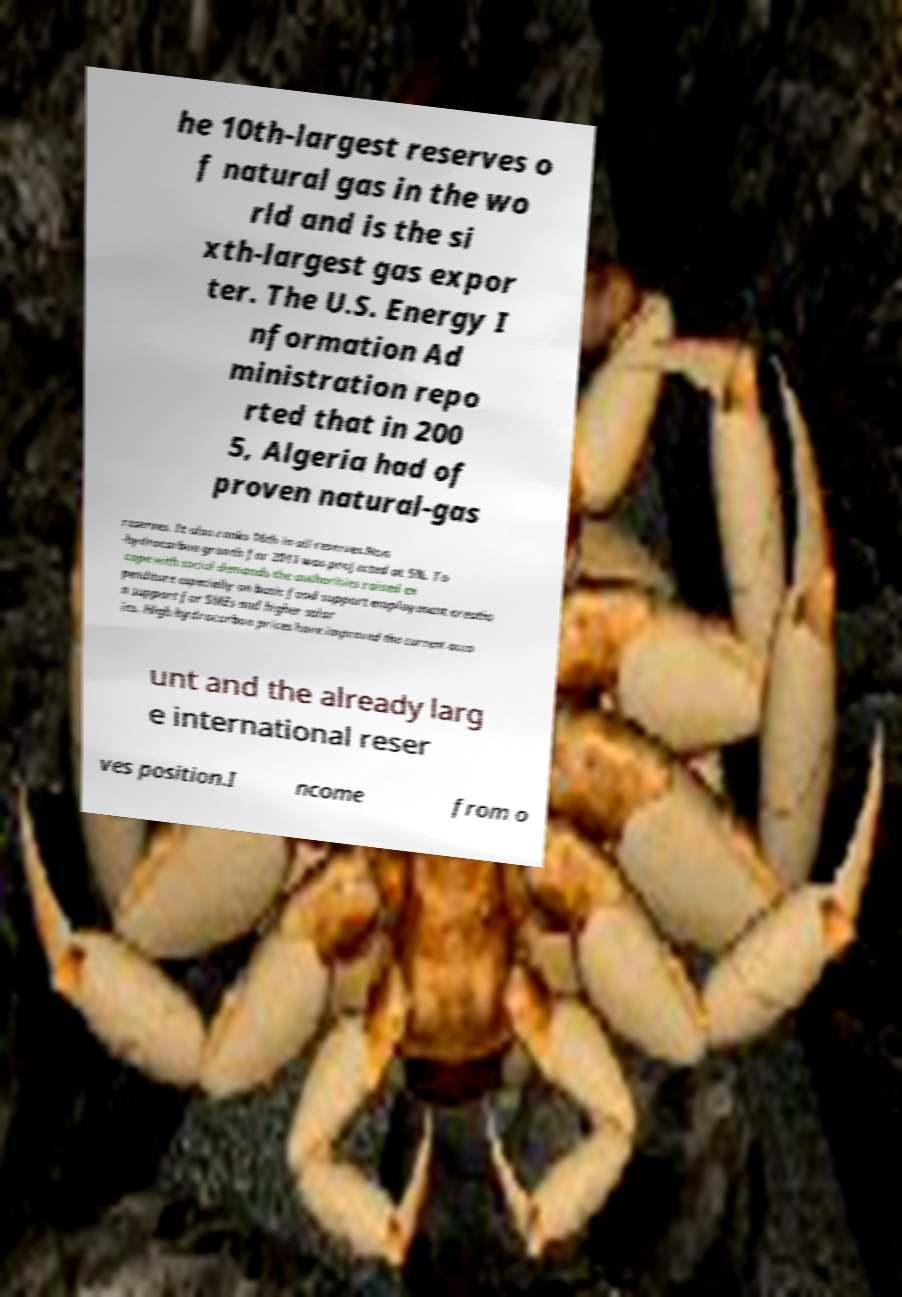There's text embedded in this image that I need extracted. Can you transcribe it verbatim? he 10th-largest reserves o f natural gas in the wo rld and is the si xth-largest gas expor ter. The U.S. Energy I nformation Ad ministration repo rted that in 200 5, Algeria had of proven natural-gas reserves. It also ranks 16th in oil reserves.Non -hydrocarbon growth for 2011 was projected at 5%. To cope with social demands the authorities raised ex penditure especially on basic food support employment creatio n support for SMEs and higher salar ies. High hydrocarbon prices have improved the current acco unt and the already larg e international reser ves position.I ncome from o 